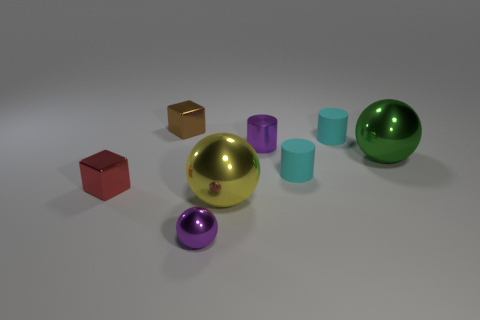Are there any other things that have the same material as the purple cylinder?
Give a very brief answer. Yes. The metallic sphere that is on the right side of the yellow thing is what color?
Your answer should be compact. Green. What is the shape of the red object that is the same material as the big yellow object?
Your response must be concise. Cube. Are there any other things that are the same color as the small shiny cylinder?
Keep it short and to the point. Yes. Are there more objects that are behind the red metallic block than objects right of the small purple cylinder?
Make the answer very short. Yes. How many spheres have the same size as the yellow shiny object?
Provide a short and direct response. 1. Is the number of tiny purple cylinders on the left side of the tiny metal ball less than the number of spheres to the left of the green ball?
Provide a succinct answer. Yes. Is there a small blue matte thing of the same shape as the red shiny thing?
Your answer should be compact. No. Is the shape of the large green metal thing the same as the tiny brown metal thing?
Your response must be concise. No. How many tiny objects are blocks or cyan matte cylinders?
Your answer should be very brief. 4. 